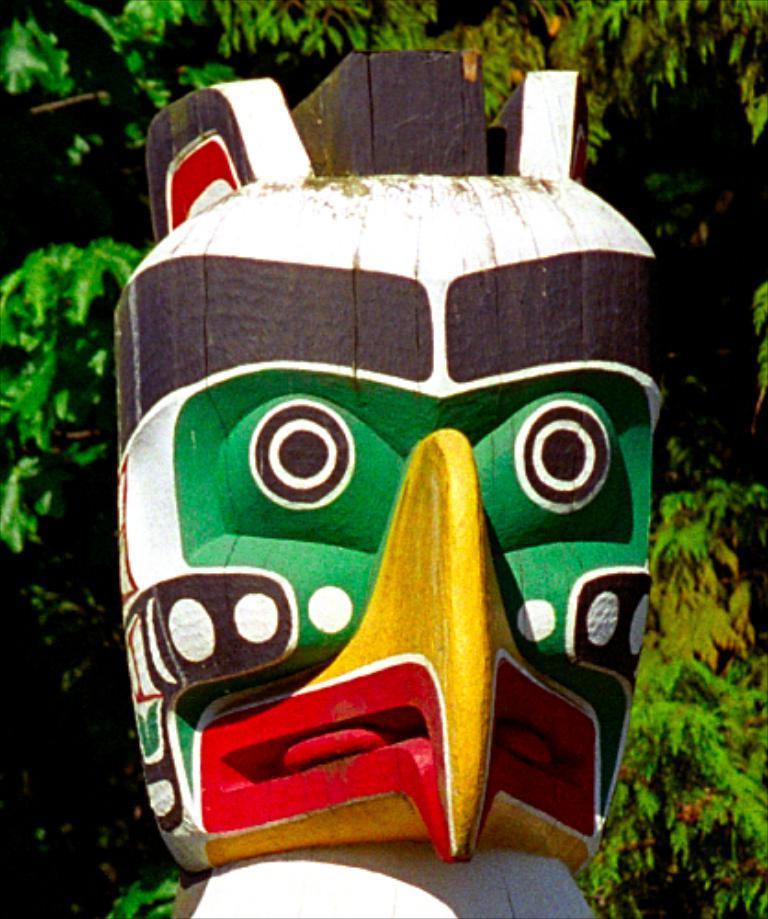How would you summarize this image in a sentence or two? In the foreground of this picture, there is a man made wooden like structure is placed in the middle of the picture. In the background, we can see the tree. 